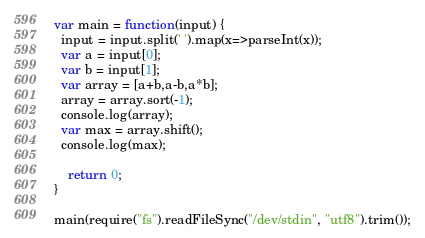Convert code to text. <code><loc_0><loc_0><loc_500><loc_500><_JavaScript_>var main = function(input) {
  input = input.split(' ').map(x=>parseInt(x));
  var a = input[0];
  var b = input[1];
  var array = [a+b,a-b,a*b];
  array = array.sort(-1);
  console.log(array);
  var max = array.shift();
  console.log(max);

    return 0; 
}

main(require("fs").readFileSync("/dev/stdin", "utf8").trim());</code> 